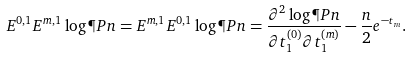<formula> <loc_0><loc_0><loc_500><loc_500>E ^ { 0 , 1 } E ^ { m , 1 } \log \P P n = E ^ { m , 1 } E ^ { 0 , 1 } \log \P P n = \frac { \partial ^ { 2 } \log \P P n } { \partial t ^ { ( 0 ) } _ { 1 } \partial t ^ { ( m ) } _ { 1 } } - \frac { n } { 2 } e ^ { - t _ { m } } .</formula> 